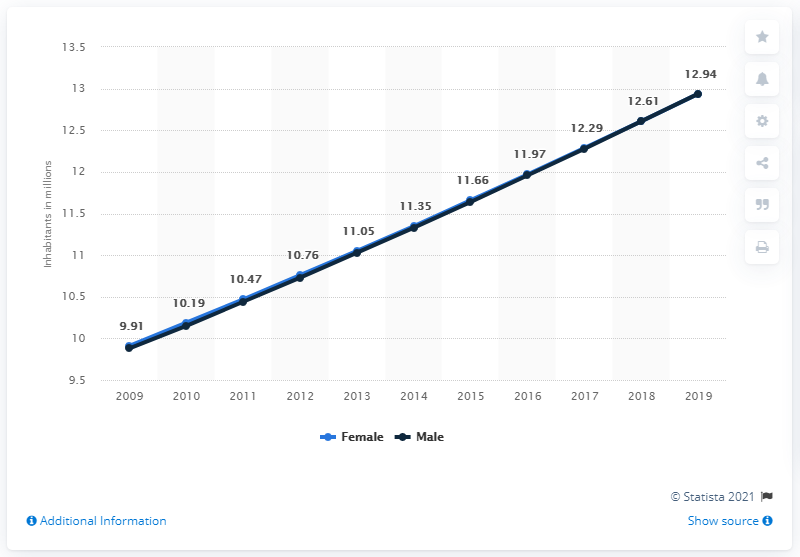Identify some key points in this picture. In 2019, the female population of Cameroon was estimated to be 12.94 million. As of 2019, the female population of Cameroon was estimated to be 12.94 million. 